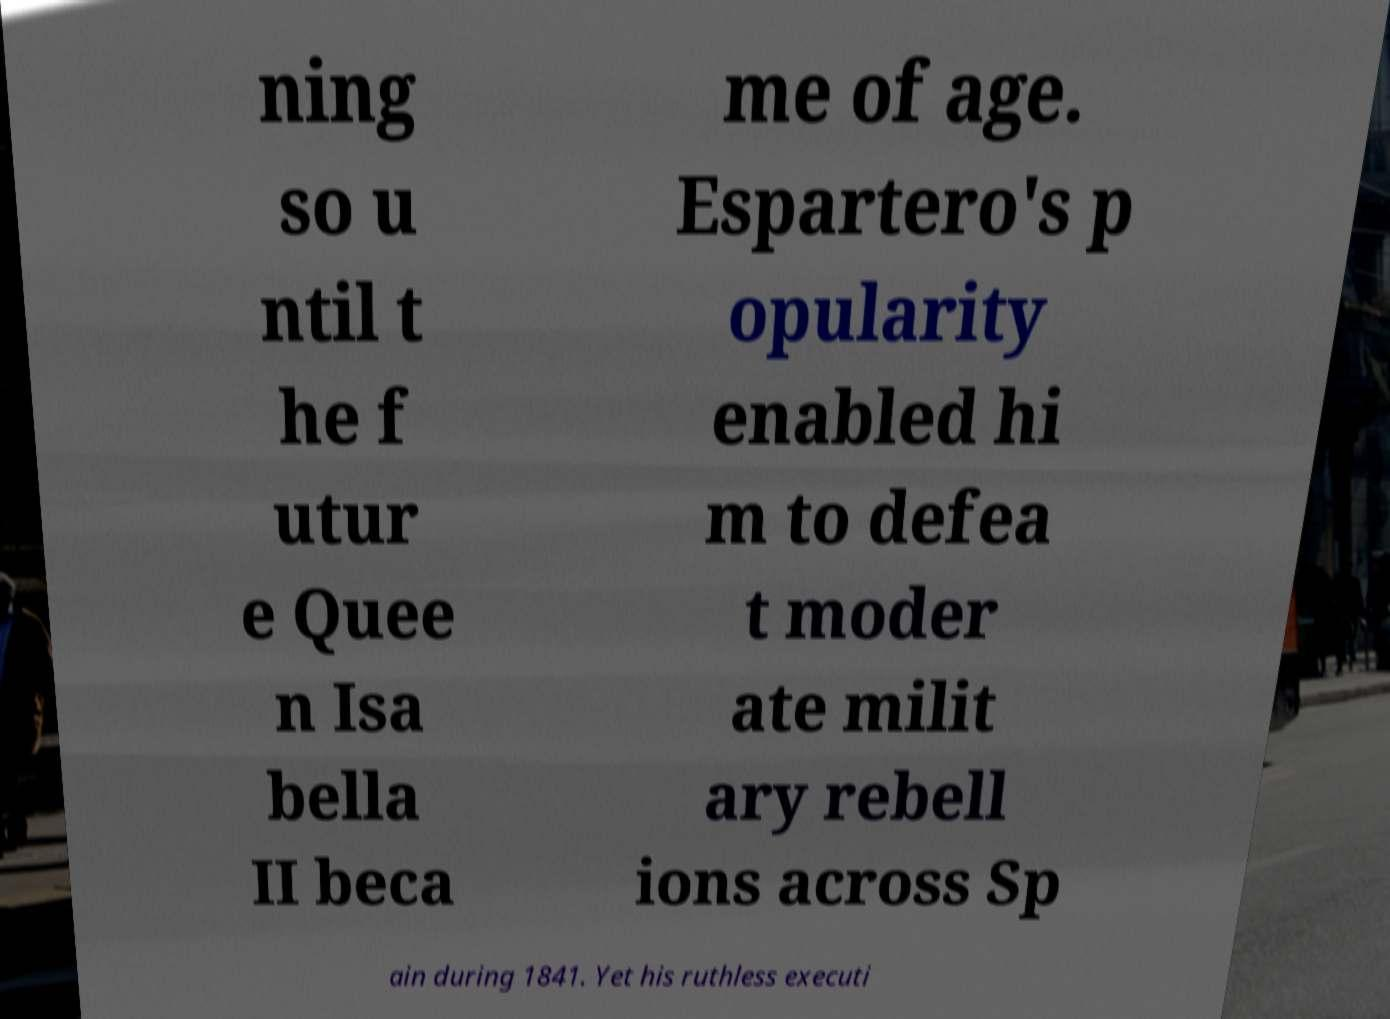Please read and relay the text visible in this image. What does it say? ning so u ntil t he f utur e Quee n Isa bella II beca me of age. Espartero's p opularity enabled hi m to defea t moder ate milit ary rebell ions across Sp ain during 1841. Yet his ruthless executi 